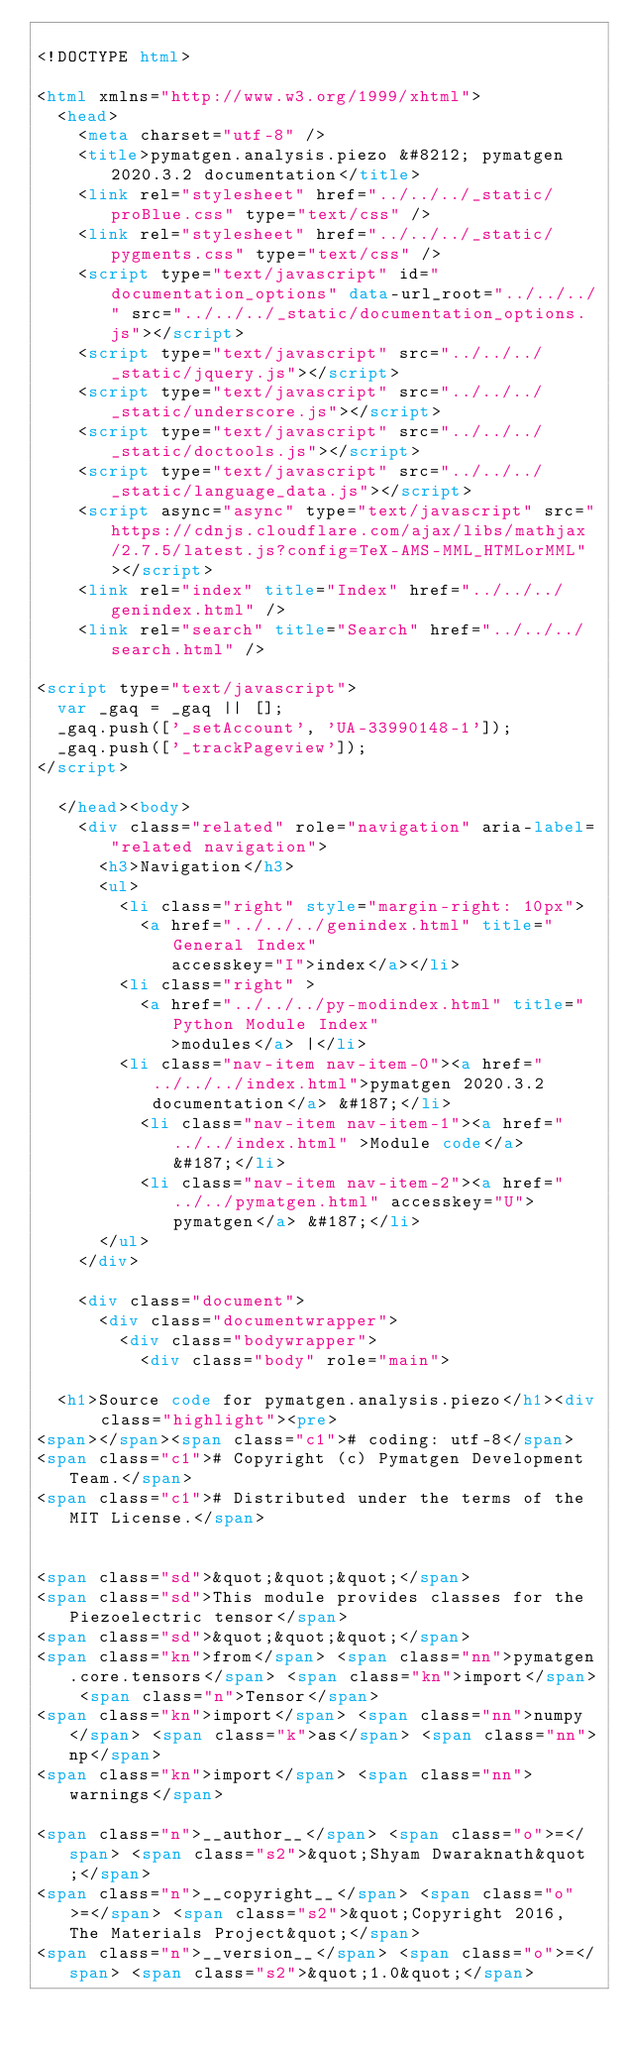<code> <loc_0><loc_0><loc_500><loc_500><_HTML_>
<!DOCTYPE html>

<html xmlns="http://www.w3.org/1999/xhtml">
  <head>
    <meta charset="utf-8" />
    <title>pymatgen.analysis.piezo &#8212; pymatgen 2020.3.2 documentation</title>
    <link rel="stylesheet" href="../../../_static/proBlue.css" type="text/css" />
    <link rel="stylesheet" href="../../../_static/pygments.css" type="text/css" />
    <script type="text/javascript" id="documentation_options" data-url_root="../../../" src="../../../_static/documentation_options.js"></script>
    <script type="text/javascript" src="../../../_static/jquery.js"></script>
    <script type="text/javascript" src="../../../_static/underscore.js"></script>
    <script type="text/javascript" src="../../../_static/doctools.js"></script>
    <script type="text/javascript" src="../../../_static/language_data.js"></script>
    <script async="async" type="text/javascript" src="https://cdnjs.cloudflare.com/ajax/libs/mathjax/2.7.5/latest.js?config=TeX-AMS-MML_HTMLorMML"></script>
    <link rel="index" title="Index" href="../../../genindex.html" />
    <link rel="search" title="Search" href="../../../search.html" />
 
<script type="text/javascript">
  var _gaq = _gaq || [];
  _gaq.push(['_setAccount', 'UA-33990148-1']);
  _gaq.push(['_trackPageview']);
</script>

  </head><body>
    <div class="related" role="navigation" aria-label="related navigation">
      <h3>Navigation</h3>
      <ul>
        <li class="right" style="margin-right: 10px">
          <a href="../../../genindex.html" title="General Index"
             accesskey="I">index</a></li>
        <li class="right" >
          <a href="../../../py-modindex.html" title="Python Module Index"
             >modules</a> |</li>
        <li class="nav-item nav-item-0"><a href="../../../index.html">pymatgen 2020.3.2 documentation</a> &#187;</li>
          <li class="nav-item nav-item-1"><a href="../../index.html" >Module code</a> &#187;</li>
          <li class="nav-item nav-item-2"><a href="../../pymatgen.html" accesskey="U">pymatgen</a> &#187;</li> 
      </ul>
    </div>  

    <div class="document">
      <div class="documentwrapper">
        <div class="bodywrapper">
          <div class="body" role="main">
            
  <h1>Source code for pymatgen.analysis.piezo</h1><div class="highlight"><pre>
<span></span><span class="c1"># coding: utf-8</span>
<span class="c1"># Copyright (c) Pymatgen Development Team.</span>
<span class="c1"># Distributed under the terms of the MIT License.</span>


<span class="sd">&quot;&quot;&quot;</span>
<span class="sd">This module provides classes for the Piezoelectric tensor</span>
<span class="sd">&quot;&quot;&quot;</span>
<span class="kn">from</span> <span class="nn">pymatgen.core.tensors</span> <span class="kn">import</span> <span class="n">Tensor</span>
<span class="kn">import</span> <span class="nn">numpy</span> <span class="k">as</span> <span class="nn">np</span>
<span class="kn">import</span> <span class="nn">warnings</span>

<span class="n">__author__</span> <span class="o">=</span> <span class="s2">&quot;Shyam Dwaraknath&quot;</span>
<span class="n">__copyright__</span> <span class="o">=</span> <span class="s2">&quot;Copyright 2016, The Materials Project&quot;</span>
<span class="n">__version__</span> <span class="o">=</span> <span class="s2">&quot;1.0&quot;</span></code> 